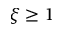Convert formula to latex. <formula><loc_0><loc_0><loc_500><loc_500>\xi \geq 1</formula> 